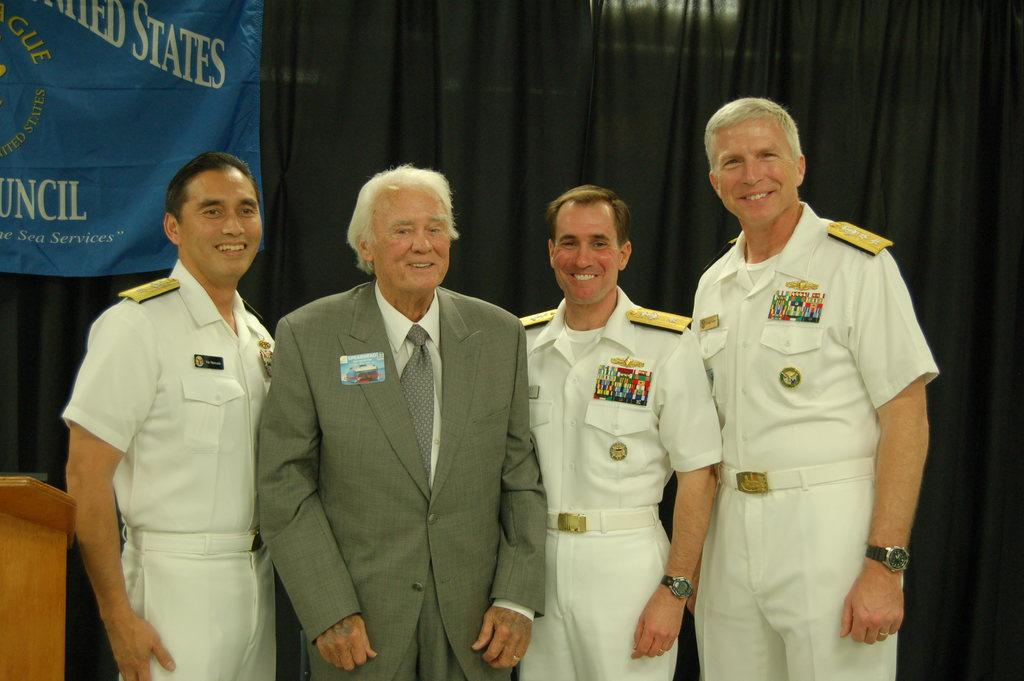<image>
Present a compact description of the photo's key features. the flag behind the men says United States 